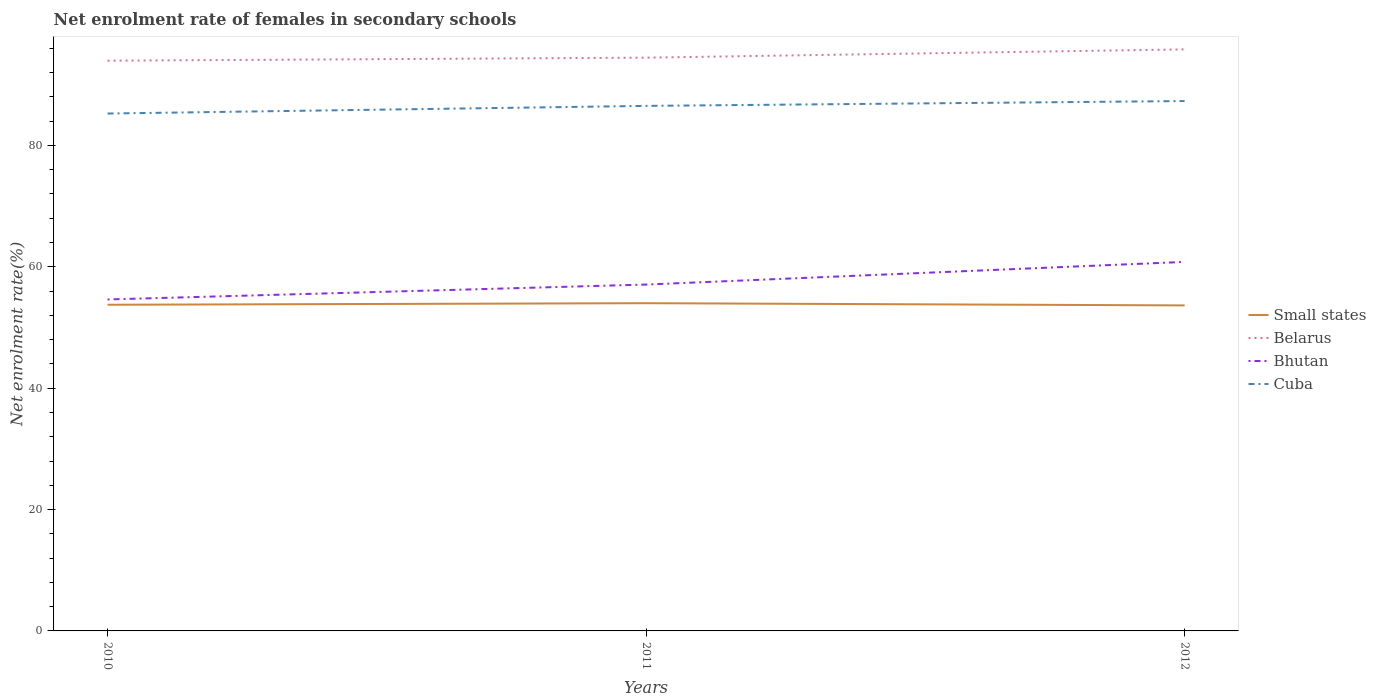Does the line corresponding to Bhutan intersect with the line corresponding to Small states?
Provide a short and direct response. No. Is the number of lines equal to the number of legend labels?
Keep it short and to the point. Yes. Across all years, what is the maximum net enrolment rate of females in secondary schools in Bhutan?
Offer a terse response. 54.62. In which year was the net enrolment rate of females in secondary schools in Bhutan maximum?
Keep it short and to the point. 2010. What is the total net enrolment rate of females in secondary schools in Bhutan in the graph?
Give a very brief answer. -2.45. What is the difference between the highest and the second highest net enrolment rate of females in secondary schools in Bhutan?
Offer a very short reply. 6.19. What is the difference between the highest and the lowest net enrolment rate of females in secondary schools in Small states?
Offer a very short reply. 1. How many lines are there?
Your response must be concise. 4. How many years are there in the graph?
Provide a short and direct response. 3. Does the graph contain any zero values?
Ensure brevity in your answer.  No. Does the graph contain grids?
Keep it short and to the point. No. Where does the legend appear in the graph?
Your answer should be very brief. Center right. What is the title of the graph?
Your answer should be compact. Net enrolment rate of females in secondary schools. Does "Caribbean small states" appear as one of the legend labels in the graph?
Provide a succinct answer. No. What is the label or title of the Y-axis?
Your answer should be compact. Net enrolment rate(%). What is the Net enrolment rate(%) of Small states in 2010?
Your response must be concise. 53.75. What is the Net enrolment rate(%) of Belarus in 2010?
Your answer should be very brief. 93.97. What is the Net enrolment rate(%) of Bhutan in 2010?
Your response must be concise. 54.62. What is the Net enrolment rate(%) of Cuba in 2010?
Provide a succinct answer. 85.26. What is the Net enrolment rate(%) in Small states in 2011?
Provide a short and direct response. 54.01. What is the Net enrolment rate(%) in Belarus in 2011?
Provide a succinct answer. 94.47. What is the Net enrolment rate(%) of Bhutan in 2011?
Offer a terse response. 57.08. What is the Net enrolment rate(%) in Cuba in 2011?
Your answer should be very brief. 86.52. What is the Net enrolment rate(%) of Small states in 2012?
Keep it short and to the point. 53.64. What is the Net enrolment rate(%) in Belarus in 2012?
Make the answer very short. 95.83. What is the Net enrolment rate(%) of Bhutan in 2012?
Offer a terse response. 60.81. What is the Net enrolment rate(%) in Cuba in 2012?
Your answer should be very brief. 87.32. Across all years, what is the maximum Net enrolment rate(%) in Small states?
Your answer should be very brief. 54.01. Across all years, what is the maximum Net enrolment rate(%) of Belarus?
Ensure brevity in your answer.  95.83. Across all years, what is the maximum Net enrolment rate(%) of Bhutan?
Provide a short and direct response. 60.81. Across all years, what is the maximum Net enrolment rate(%) of Cuba?
Offer a terse response. 87.32. Across all years, what is the minimum Net enrolment rate(%) in Small states?
Offer a terse response. 53.64. Across all years, what is the minimum Net enrolment rate(%) in Belarus?
Your answer should be compact. 93.97. Across all years, what is the minimum Net enrolment rate(%) in Bhutan?
Keep it short and to the point. 54.62. Across all years, what is the minimum Net enrolment rate(%) in Cuba?
Ensure brevity in your answer.  85.26. What is the total Net enrolment rate(%) in Small states in the graph?
Give a very brief answer. 161.4. What is the total Net enrolment rate(%) of Belarus in the graph?
Offer a terse response. 284.26. What is the total Net enrolment rate(%) in Bhutan in the graph?
Provide a succinct answer. 172.51. What is the total Net enrolment rate(%) of Cuba in the graph?
Provide a succinct answer. 259.1. What is the difference between the Net enrolment rate(%) of Small states in 2010 and that in 2011?
Give a very brief answer. -0.26. What is the difference between the Net enrolment rate(%) of Belarus in 2010 and that in 2011?
Provide a succinct answer. -0.5. What is the difference between the Net enrolment rate(%) of Bhutan in 2010 and that in 2011?
Offer a terse response. -2.45. What is the difference between the Net enrolment rate(%) of Cuba in 2010 and that in 2011?
Provide a short and direct response. -1.26. What is the difference between the Net enrolment rate(%) in Small states in 2010 and that in 2012?
Provide a succinct answer. 0.11. What is the difference between the Net enrolment rate(%) of Belarus in 2010 and that in 2012?
Provide a short and direct response. -1.87. What is the difference between the Net enrolment rate(%) of Bhutan in 2010 and that in 2012?
Ensure brevity in your answer.  -6.19. What is the difference between the Net enrolment rate(%) in Cuba in 2010 and that in 2012?
Give a very brief answer. -2.06. What is the difference between the Net enrolment rate(%) in Small states in 2011 and that in 2012?
Provide a short and direct response. 0.36. What is the difference between the Net enrolment rate(%) of Belarus in 2011 and that in 2012?
Offer a very short reply. -1.36. What is the difference between the Net enrolment rate(%) of Bhutan in 2011 and that in 2012?
Provide a succinct answer. -3.73. What is the difference between the Net enrolment rate(%) of Cuba in 2011 and that in 2012?
Your answer should be compact. -0.8. What is the difference between the Net enrolment rate(%) of Small states in 2010 and the Net enrolment rate(%) of Belarus in 2011?
Make the answer very short. -40.72. What is the difference between the Net enrolment rate(%) in Small states in 2010 and the Net enrolment rate(%) in Bhutan in 2011?
Offer a very short reply. -3.33. What is the difference between the Net enrolment rate(%) of Small states in 2010 and the Net enrolment rate(%) of Cuba in 2011?
Your answer should be compact. -32.77. What is the difference between the Net enrolment rate(%) of Belarus in 2010 and the Net enrolment rate(%) of Bhutan in 2011?
Your answer should be very brief. 36.89. What is the difference between the Net enrolment rate(%) of Belarus in 2010 and the Net enrolment rate(%) of Cuba in 2011?
Offer a very short reply. 7.45. What is the difference between the Net enrolment rate(%) in Bhutan in 2010 and the Net enrolment rate(%) in Cuba in 2011?
Your answer should be compact. -31.9. What is the difference between the Net enrolment rate(%) of Small states in 2010 and the Net enrolment rate(%) of Belarus in 2012?
Your answer should be very brief. -42.08. What is the difference between the Net enrolment rate(%) of Small states in 2010 and the Net enrolment rate(%) of Bhutan in 2012?
Provide a short and direct response. -7.06. What is the difference between the Net enrolment rate(%) in Small states in 2010 and the Net enrolment rate(%) in Cuba in 2012?
Give a very brief answer. -33.57. What is the difference between the Net enrolment rate(%) of Belarus in 2010 and the Net enrolment rate(%) of Bhutan in 2012?
Keep it short and to the point. 33.16. What is the difference between the Net enrolment rate(%) in Belarus in 2010 and the Net enrolment rate(%) in Cuba in 2012?
Make the answer very short. 6.65. What is the difference between the Net enrolment rate(%) of Bhutan in 2010 and the Net enrolment rate(%) of Cuba in 2012?
Ensure brevity in your answer.  -32.69. What is the difference between the Net enrolment rate(%) of Small states in 2011 and the Net enrolment rate(%) of Belarus in 2012?
Keep it short and to the point. -41.83. What is the difference between the Net enrolment rate(%) of Small states in 2011 and the Net enrolment rate(%) of Bhutan in 2012?
Your answer should be very brief. -6.8. What is the difference between the Net enrolment rate(%) of Small states in 2011 and the Net enrolment rate(%) of Cuba in 2012?
Provide a short and direct response. -33.31. What is the difference between the Net enrolment rate(%) of Belarus in 2011 and the Net enrolment rate(%) of Bhutan in 2012?
Your answer should be very brief. 33.66. What is the difference between the Net enrolment rate(%) of Belarus in 2011 and the Net enrolment rate(%) of Cuba in 2012?
Your answer should be compact. 7.15. What is the difference between the Net enrolment rate(%) in Bhutan in 2011 and the Net enrolment rate(%) in Cuba in 2012?
Provide a succinct answer. -30.24. What is the average Net enrolment rate(%) in Small states per year?
Your response must be concise. 53.8. What is the average Net enrolment rate(%) of Belarus per year?
Your answer should be compact. 94.75. What is the average Net enrolment rate(%) in Bhutan per year?
Make the answer very short. 57.5. What is the average Net enrolment rate(%) of Cuba per year?
Give a very brief answer. 86.37. In the year 2010, what is the difference between the Net enrolment rate(%) in Small states and Net enrolment rate(%) in Belarus?
Make the answer very short. -40.22. In the year 2010, what is the difference between the Net enrolment rate(%) of Small states and Net enrolment rate(%) of Bhutan?
Offer a terse response. -0.87. In the year 2010, what is the difference between the Net enrolment rate(%) in Small states and Net enrolment rate(%) in Cuba?
Provide a succinct answer. -31.51. In the year 2010, what is the difference between the Net enrolment rate(%) in Belarus and Net enrolment rate(%) in Bhutan?
Ensure brevity in your answer.  39.34. In the year 2010, what is the difference between the Net enrolment rate(%) of Belarus and Net enrolment rate(%) of Cuba?
Provide a short and direct response. 8.71. In the year 2010, what is the difference between the Net enrolment rate(%) in Bhutan and Net enrolment rate(%) in Cuba?
Your response must be concise. -30.64. In the year 2011, what is the difference between the Net enrolment rate(%) of Small states and Net enrolment rate(%) of Belarus?
Your answer should be very brief. -40.46. In the year 2011, what is the difference between the Net enrolment rate(%) in Small states and Net enrolment rate(%) in Bhutan?
Your answer should be compact. -3.07. In the year 2011, what is the difference between the Net enrolment rate(%) in Small states and Net enrolment rate(%) in Cuba?
Ensure brevity in your answer.  -32.51. In the year 2011, what is the difference between the Net enrolment rate(%) of Belarus and Net enrolment rate(%) of Bhutan?
Offer a very short reply. 37.39. In the year 2011, what is the difference between the Net enrolment rate(%) of Belarus and Net enrolment rate(%) of Cuba?
Give a very brief answer. 7.95. In the year 2011, what is the difference between the Net enrolment rate(%) in Bhutan and Net enrolment rate(%) in Cuba?
Offer a very short reply. -29.44. In the year 2012, what is the difference between the Net enrolment rate(%) of Small states and Net enrolment rate(%) of Belarus?
Your response must be concise. -42.19. In the year 2012, what is the difference between the Net enrolment rate(%) of Small states and Net enrolment rate(%) of Bhutan?
Make the answer very short. -7.17. In the year 2012, what is the difference between the Net enrolment rate(%) of Small states and Net enrolment rate(%) of Cuba?
Give a very brief answer. -33.68. In the year 2012, what is the difference between the Net enrolment rate(%) in Belarus and Net enrolment rate(%) in Bhutan?
Your answer should be very brief. 35.02. In the year 2012, what is the difference between the Net enrolment rate(%) of Belarus and Net enrolment rate(%) of Cuba?
Your response must be concise. 8.51. In the year 2012, what is the difference between the Net enrolment rate(%) of Bhutan and Net enrolment rate(%) of Cuba?
Give a very brief answer. -26.51. What is the ratio of the Net enrolment rate(%) in Small states in 2010 to that in 2011?
Your response must be concise. 1. What is the ratio of the Net enrolment rate(%) of Belarus in 2010 to that in 2011?
Offer a very short reply. 0.99. What is the ratio of the Net enrolment rate(%) of Bhutan in 2010 to that in 2011?
Your answer should be compact. 0.96. What is the ratio of the Net enrolment rate(%) of Cuba in 2010 to that in 2011?
Ensure brevity in your answer.  0.99. What is the ratio of the Net enrolment rate(%) of Belarus in 2010 to that in 2012?
Ensure brevity in your answer.  0.98. What is the ratio of the Net enrolment rate(%) of Bhutan in 2010 to that in 2012?
Your answer should be compact. 0.9. What is the ratio of the Net enrolment rate(%) of Cuba in 2010 to that in 2012?
Ensure brevity in your answer.  0.98. What is the ratio of the Net enrolment rate(%) of Small states in 2011 to that in 2012?
Make the answer very short. 1.01. What is the ratio of the Net enrolment rate(%) in Belarus in 2011 to that in 2012?
Keep it short and to the point. 0.99. What is the ratio of the Net enrolment rate(%) in Bhutan in 2011 to that in 2012?
Offer a terse response. 0.94. What is the ratio of the Net enrolment rate(%) in Cuba in 2011 to that in 2012?
Offer a terse response. 0.99. What is the difference between the highest and the second highest Net enrolment rate(%) in Small states?
Your answer should be compact. 0.26. What is the difference between the highest and the second highest Net enrolment rate(%) in Belarus?
Provide a short and direct response. 1.36. What is the difference between the highest and the second highest Net enrolment rate(%) of Bhutan?
Offer a very short reply. 3.73. What is the difference between the highest and the second highest Net enrolment rate(%) of Cuba?
Make the answer very short. 0.8. What is the difference between the highest and the lowest Net enrolment rate(%) in Small states?
Ensure brevity in your answer.  0.36. What is the difference between the highest and the lowest Net enrolment rate(%) of Belarus?
Offer a terse response. 1.87. What is the difference between the highest and the lowest Net enrolment rate(%) of Bhutan?
Make the answer very short. 6.19. What is the difference between the highest and the lowest Net enrolment rate(%) in Cuba?
Provide a short and direct response. 2.06. 